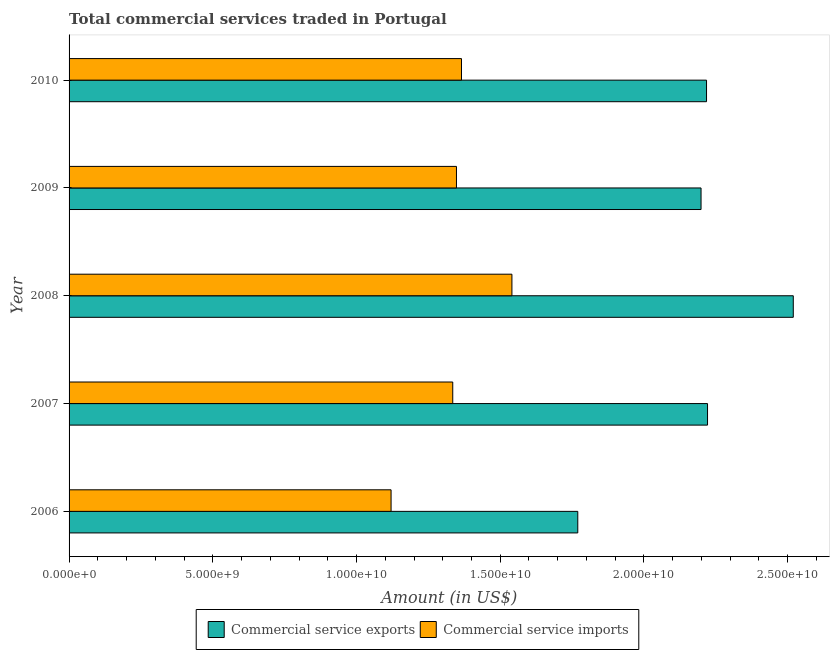How many different coloured bars are there?
Keep it short and to the point. 2. How many groups of bars are there?
Make the answer very short. 5. Are the number of bars per tick equal to the number of legend labels?
Offer a very short reply. Yes. What is the label of the 3rd group of bars from the top?
Provide a short and direct response. 2008. What is the amount of commercial service exports in 2008?
Make the answer very short. 2.52e+1. Across all years, what is the maximum amount of commercial service exports?
Your answer should be very brief. 2.52e+1. Across all years, what is the minimum amount of commercial service exports?
Ensure brevity in your answer.  1.77e+1. In which year was the amount of commercial service exports maximum?
Your answer should be compact. 2008. In which year was the amount of commercial service exports minimum?
Give a very brief answer. 2006. What is the total amount of commercial service exports in the graph?
Your response must be concise. 1.09e+11. What is the difference between the amount of commercial service exports in 2006 and that in 2009?
Provide a succinct answer. -4.29e+09. What is the difference between the amount of commercial service exports in 2009 and the amount of commercial service imports in 2006?
Keep it short and to the point. 1.08e+1. What is the average amount of commercial service imports per year?
Offer a terse response. 1.34e+1. In the year 2010, what is the difference between the amount of commercial service exports and amount of commercial service imports?
Keep it short and to the point. 8.52e+09. What is the difference between the highest and the second highest amount of commercial service imports?
Your response must be concise. 1.75e+09. What is the difference between the highest and the lowest amount of commercial service imports?
Make the answer very short. 4.20e+09. What does the 1st bar from the top in 2010 represents?
Give a very brief answer. Commercial service imports. What does the 1st bar from the bottom in 2007 represents?
Make the answer very short. Commercial service exports. Are all the bars in the graph horizontal?
Ensure brevity in your answer.  Yes. Are the values on the major ticks of X-axis written in scientific E-notation?
Offer a terse response. Yes. Does the graph contain any zero values?
Provide a short and direct response. No. Where does the legend appear in the graph?
Make the answer very short. Bottom center. How are the legend labels stacked?
Your answer should be very brief. Horizontal. What is the title of the graph?
Your answer should be very brief. Total commercial services traded in Portugal. What is the Amount (in US$) of Commercial service exports in 2006?
Give a very brief answer. 1.77e+1. What is the Amount (in US$) of Commercial service imports in 2006?
Your answer should be very brief. 1.12e+1. What is the Amount (in US$) of Commercial service exports in 2007?
Your response must be concise. 2.22e+1. What is the Amount (in US$) in Commercial service imports in 2007?
Provide a succinct answer. 1.33e+1. What is the Amount (in US$) of Commercial service exports in 2008?
Provide a succinct answer. 2.52e+1. What is the Amount (in US$) of Commercial service imports in 2008?
Your answer should be compact. 1.54e+1. What is the Amount (in US$) in Commercial service exports in 2009?
Your answer should be compact. 2.20e+1. What is the Amount (in US$) of Commercial service imports in 2009?
Your answer should be compact. 1.35e+1. What is the Amount (in US$) of Commercial service exports in 2010?
Your answer should be compact. 2.22e+1. What is the Amount (in US$) of Commercial service imports in 2010?
Ensure brevity in your answer.  1.37e+1. Across all years, what is the maximum Amount (in US$) of Commercial service exports?
Offer a terse response. 2.52e+1. Across all years, what is the maximum Amount (in US$) in Commercial service imports?
Your response must be concise. 1.54e+1. Across all years, what is the minimum Amount (in US$) in Commercial service exports?
Your answer should be compact. 1.77e+1. Across all years, what is the minimum Amount (in US$) in Commercial service imports?
Give a very brief answer. 1.12e+1. What is the total Amount (in US$) in Commercial service exports in the graph?
Your response must be concise. 1.09e+11. What is the total Amount (in US$) of Commercial service imports in the graph?
Offer a very short reply. 6.71e+1. What is the difference between the Amount (in US$) of Commercial service exports in 2006 and that in 2007?
Ensure brevity in your answer.  -4.51e+09. What is the difference between the Amount (in US$) of Commercial service imports in 2006 and that in 2007?
Provide a succinct answer. -2.15e+09. What is the difference between the Amount (in US$) in Commercial service exports in 2006 and that in 2008?
Offer a very short reply. -7.50e+09. What is the difference between the Amount (in US$) in Commercial service imports in 2006 and that in 2008?
Provide a short and direct response. -4.20e+09. What is the difference between the Amount (in US$) of Commercial service exports in 2006 and that in 2009?
Your response must be concise. -4.29e+09. What is the difference between the Amount (in US$) of Commercial service imports in 2006 and that in 2009?
Ensure brevity in your answer.  -2.28e+09. What is the difference between the Amount (in US$) of Commercial service exports in 2006 and that in 2010?
Make the answer very short. -4.48e+09. What is the difference between the Amount (in US$) in Commercial service imports in 2006 and that in 2010?
Keep it short and to the point. -2.45e+09. What is the difference between the Amount (in US$) of Commercial service exports in 2007 and that in 2008?
Make the answer very short. -2.98e+09. What is the difference between the Amount (in US$) of Commercial service imports in 2007 and that in 2008?
Offer a terse response. -2.06e+09. What is the difference between the Amount (in US$) in Commercial service exports in 2007 and that in 2009?
Your answer should be very brief. 2.26e+08. What is the difference between the Amount (in US$) of Commercial service imports in 2007 and that in 2009?
Ensure brevity in your answer.  -1.29e+08. What is the difference between the Amount (in US$) in Commercial service exports in 2007 and that in 2010?
Keep it short and to the point. 3.52e+07. What is the difference between the Amount (in US$) of Commercial service imports in 2007 and that in 2010?
Give a very brief answer. -3.04e+08. What is the difference between the Amount (in US$) in Commercial service exports in 2008 and that in 2009?
Keep it short and to the point. 3.21e+09. What is the difference between the Amount (in US$) of Commercial service imports in 2008 and that in 2009?
Your answer should be very brief. 1.93e+09. What is the difference between the Amount (in US$) in Commercial service exports in 2008 and that in 2010?
Offer a terse response. 3.02e+09. What is the difference between the Amount (in US$) of Commercial service imports in 2008 and that in 2010?
Make the answer very short. 1.75e+09. What is the difference between the Amount (in US$) in Commercial service exports in 2009 and that in 2010?
Offer a terse response. -1.91e+08. What is the difference between the Amount (in US$) in Commercial service imports in 2009 and that in 2010?
Ensure brevity in your answer.  -1.75e+08. What is the difference between the Amount (in US$) in Commercial service exports in 2006 and the Amount (in US$) in Commercial service imports in 2007?
Your answer should be very brief. 4.35e+09. What is the difference between the Amount (in US$) of Commercial service exports in 2006 and the Amount (in US$) of Commercial service imports in 2008?
Make the answer very short. 2.29e+09. What is the difference between the Amount (in US$) of Commercial service exports in 2006 and the Amount (in US$) of Commercial service imports in 2009?
Offer a terse response. 4.22e+09. What is the difference between the Amount (in US$) of Commercial service exports in 2006 and the Amount (in US$) of Commercial service imports in 2010?
Offer a terse response. 4.05e+09. What is the difference between the Amount (in US$) in Commercial service exports in 2007 and the Amount (in US$) in Commercial service imports in 2008?
Offer a very short reply. 6.81e+09. What is the difference between the Amount (in US$) of Commercial service exports in 2007 and the Amount (in US$) of Commercial service imports in 2009?
Your answer should be compact. 8.73e+09. What is the difference between the Amount (in US$) of Commercial service exports in 2007 and the Amount (in US$) of Commercial service imports in 2010?
Ensure brevity in your answer.  8.56e+09. What is the difference between the Amount (in US$) in Commercial service exports in 2008 and the Amount (in US$) in Commercial service imports in 2009?
Your answer should be very brief. 1.17e+1. What is the difference between the Amount (in US$) in Commercial service exports in 2008 and the Amount (in US$) in Commercial service imports in 2010?
Your answer should be compact. 1.15e+1. What is the difference between the Amount (in US$) in Commercial service exports in 2009 and the Amount (in US$) in Commercial service imports in 2010?
Keep it short and to the point. 8.33e+09. What is the average Amount (in US$) in Commercial service exports per year?
Your answer should be very brief. 2.19e+1. What is the average Amount (in US$) of Commercial service imports per year?
Provide a succinct answer. 1.34e+1. In the year 2006, what is the difference between the Amount (in US$) of Commercial service exports and Amount (in US$) of Commercial service imports?
Ensure brevity in your answer.  6.50e+09. In the year 2007, what is the difference between the Amount (in US$) in Commercial service exports and Amount (in US$) in Commercial service imports?
Offer a very short reply. 8.86e+09. In the year 2008, what is the difference between the Amount (in US$) of Commercial service exports and Amount (in US$) of Commercial service imports?
Ensure brevity in your answer.  9.79e+09. In the year 2009, what is the difference between the Amount (in US$) in Commercial service exports and Amount (in US$) in Commercial service imports?
Offer a very short reply. 8.51e+09. In the year 2010, what is the difference between the Amount (in US$) of Commercial service exports and Amount (in US$) of Commercial service imports?
Ensure brevity in your answer.  8.52e+09. What is the ratio of the Amount (in US$) in Commercial service exports in 2006 to that in 2007?
Offer a very short reply. 0.8. What is the ratio of the Amount (in US$) in Commercial service imports in 2006 to that in 2007?
Your answer should be compact. 0.84. What is the ratio of the Amount (in US$) of Commercial service exports in 2006 to that in 2008?
Your answer should be very brief. 0.7. What is the ratio of the Amount (in US$) in Commercial service imports in 2006 to that in 2008?
Keep it short and to the point. 0.73. What is the ratio of the Amount (in US$) of Commercial service exports in 2006 to that in 2009?
Offer a terse response. 0.81. What is the ratio of the Amount (in US$) of Commercial service imports in 2006 to that in 2009?
Offer a terse response. 0.83. What is the ratio of the Amount (in US$) of Commercial service exports in 2006 to that in 2010?
Provide a succinct answer. 0.8. What is the ratio of the Amount (in US$) of Commercial service imports in 2006 to that in 2010?
Keep it short and to the point. 0.82. What is the ratio of the Amount (in US$) of Commercial service exports in 2007 to that in 2008?
Offer a terse response. 0.88. What is the ratio of the Amount (in US$) in Commercial service imports in 2007 to that in 2008?
Provide a succinct answer. 0.87. What is the ratio of the Amount (in US$) of Commercial service exports in 2007 to that in 2009?
Your answer should be very brief. 1.01. What is the ratio of the Amount (in US$) in Commercial service exports in 2007 to that in 2010?
Keep it short and to the point. 1. What is the ratio of the Amount (in US$) in Commercial service imports in 2007 to that in 2010?
Offer a very short reply. 0.98. What is the ratio of the Amount (in US$) of Commercial service exports in 2008 to that in 2009?
Provide a short and direct response. 1.15. What is the ratio of the Amount (in US$) of Commercial service imports in 2008 to that in 2009?
Offer a very short reply. 1.14. What is the ratio of the Amount (in US$) of Commercial service exports in 2008 to that in 2010?
Ensure brevity in your answer.  1.14. What is the ratio of the Amount (in US$) of Commercial service imports in 2008 to that in 2010?
Offer a very short reply. 1.13. What is the ratio of the Amount (in US$) in Commercial service exports in 2009 to that in 2010?
Your answer should be compact. 0.99. What is the ratio of the Amount (in US$) of Commercial service imports in 2009 to that in 2010?
Keep it short and to the point. 0.99. What is the difference between the highest and the second highest Amount (in US$) in Commercial service exports?
Offer a very short reply. 2.98e+09. What is the difference between the highest and the second highest Amount (in US$) in Commercial service imports?
Your response must be concise. 1.75e+09. What is the difference between the highest and the lowest Amount (in US$) in Commercial service exports?
Keep it short and to the point. 7.50e+09. What is the difference between the highest and the lowest Amount (in US$) in Commercial service imports?
Provide a short and direct response. 4.20e+09. 